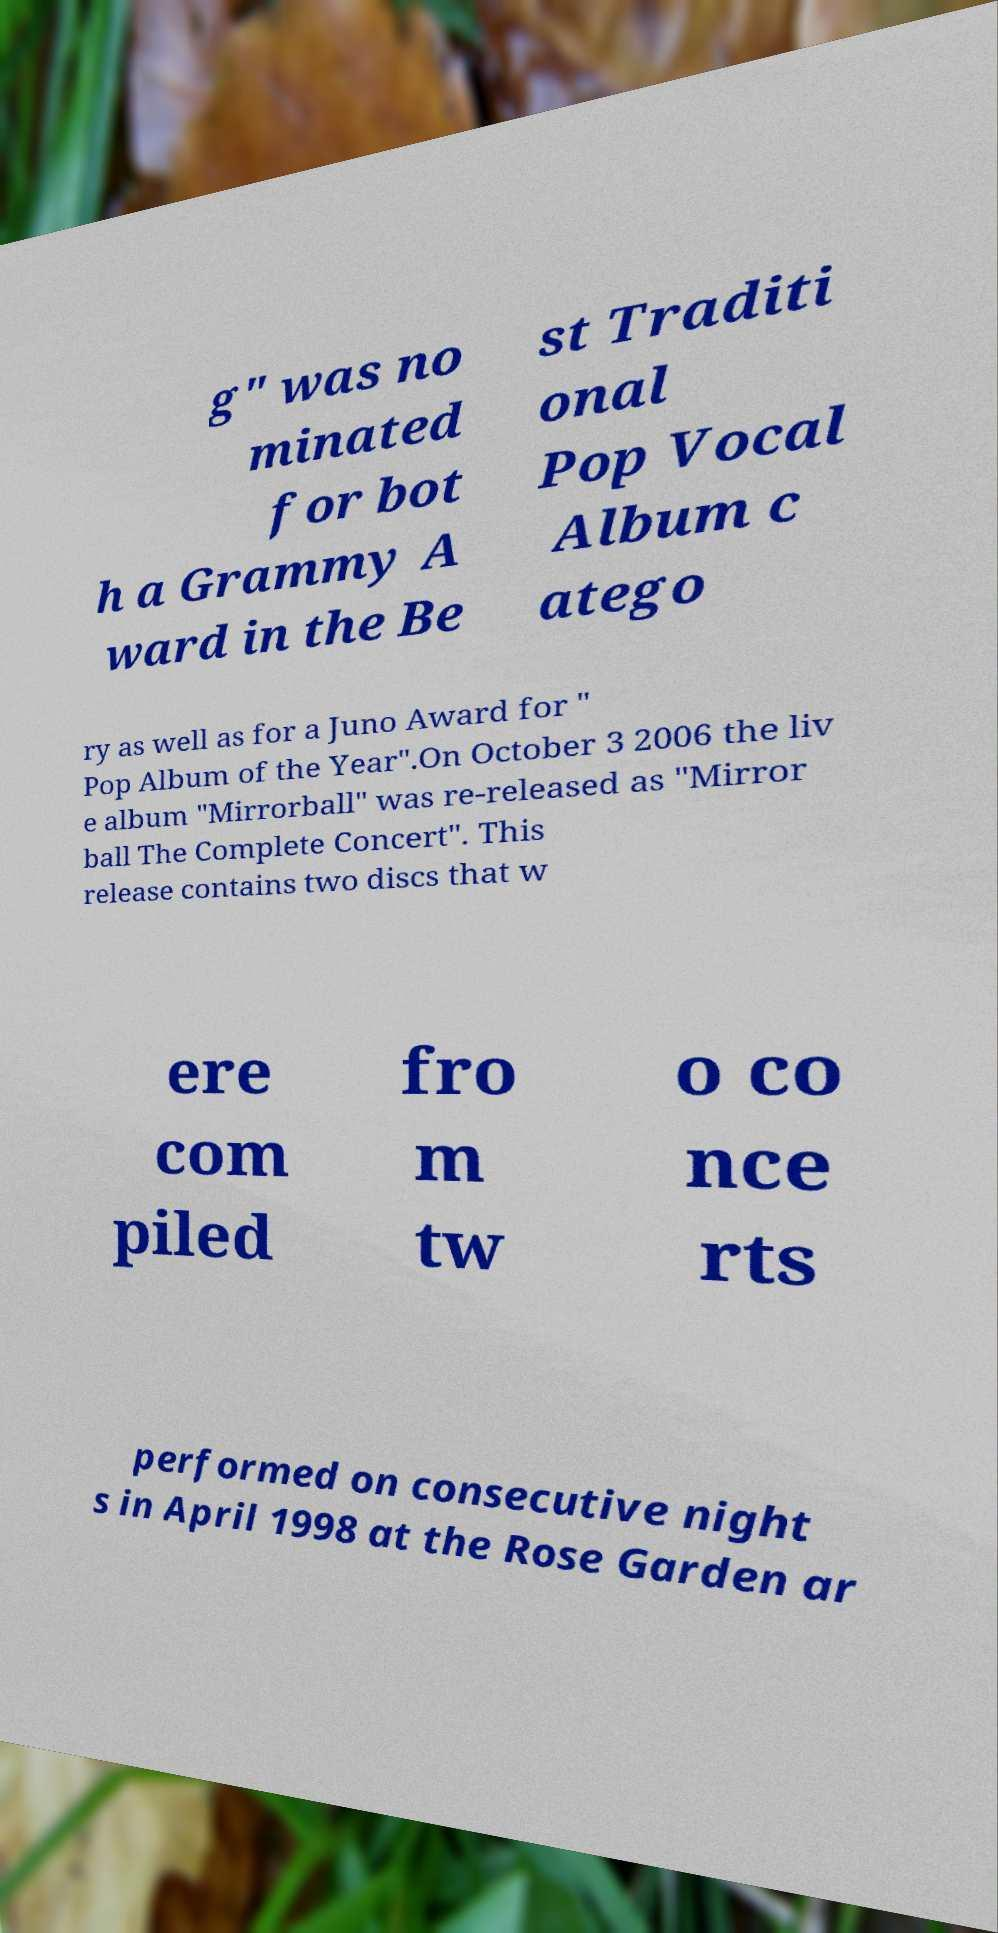Can you read and provide the text displayed in the image?This photo seems to have some interesting text. Can you extract and type it out for me? g" was no minated for bot h a Grammy A ward in the Be st Traditi onal Pop Vocal Album c atego ry as well as for a Juno Award for " Pop Album of the Year".On October 3 2006 the liv e album "Mirrorball" was re-released as "Mirror ball The Complete Concert". This release contains two discs that w ere com piled fro m tw o co nce rts performed on consecutive night s in April 1998 at the Rose Garden ar 